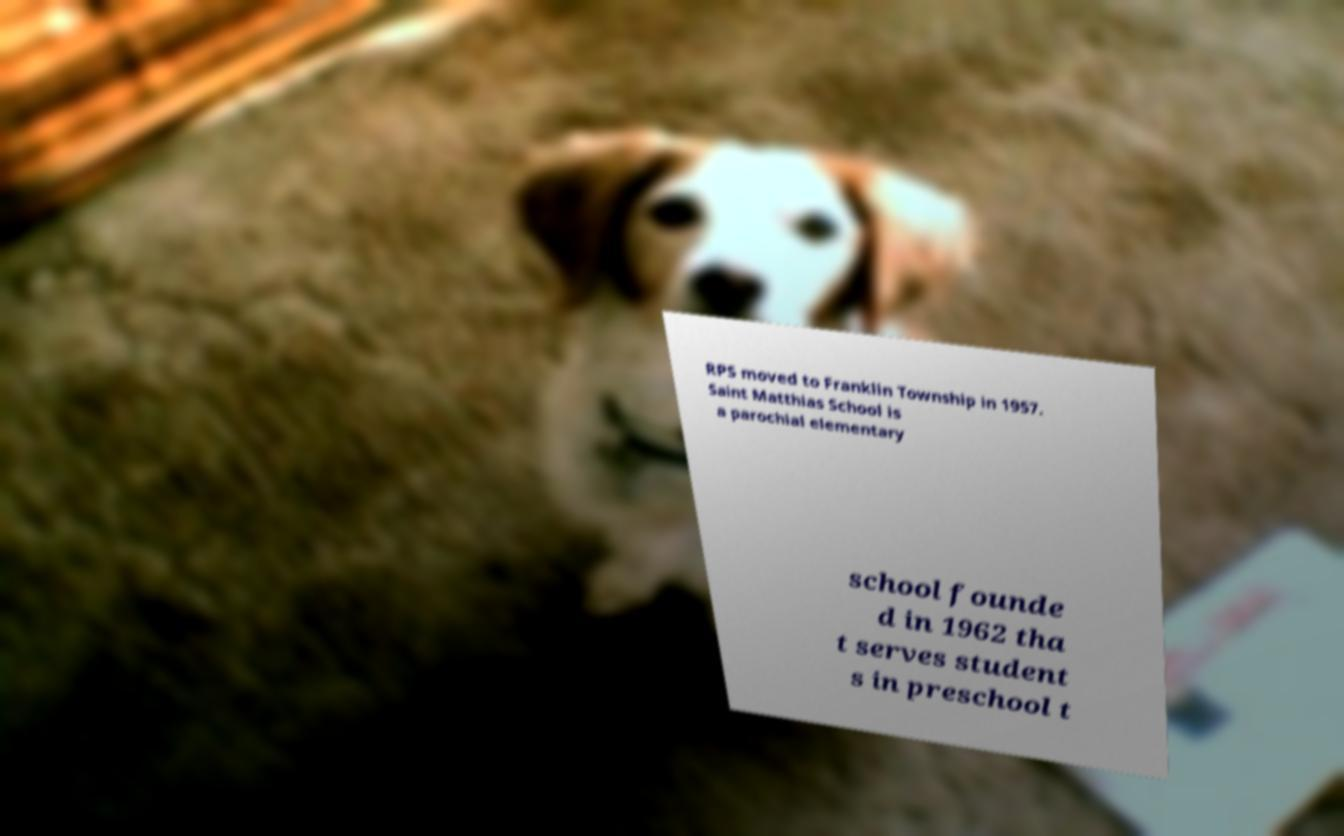What messages or text are displayed in this image? I need them in a readable, typed format. RPS moved to Franklin Township in 1957. Saint Matthias School is a parochial elementary school founde d in 1962 tha t serves student s in preschool t 